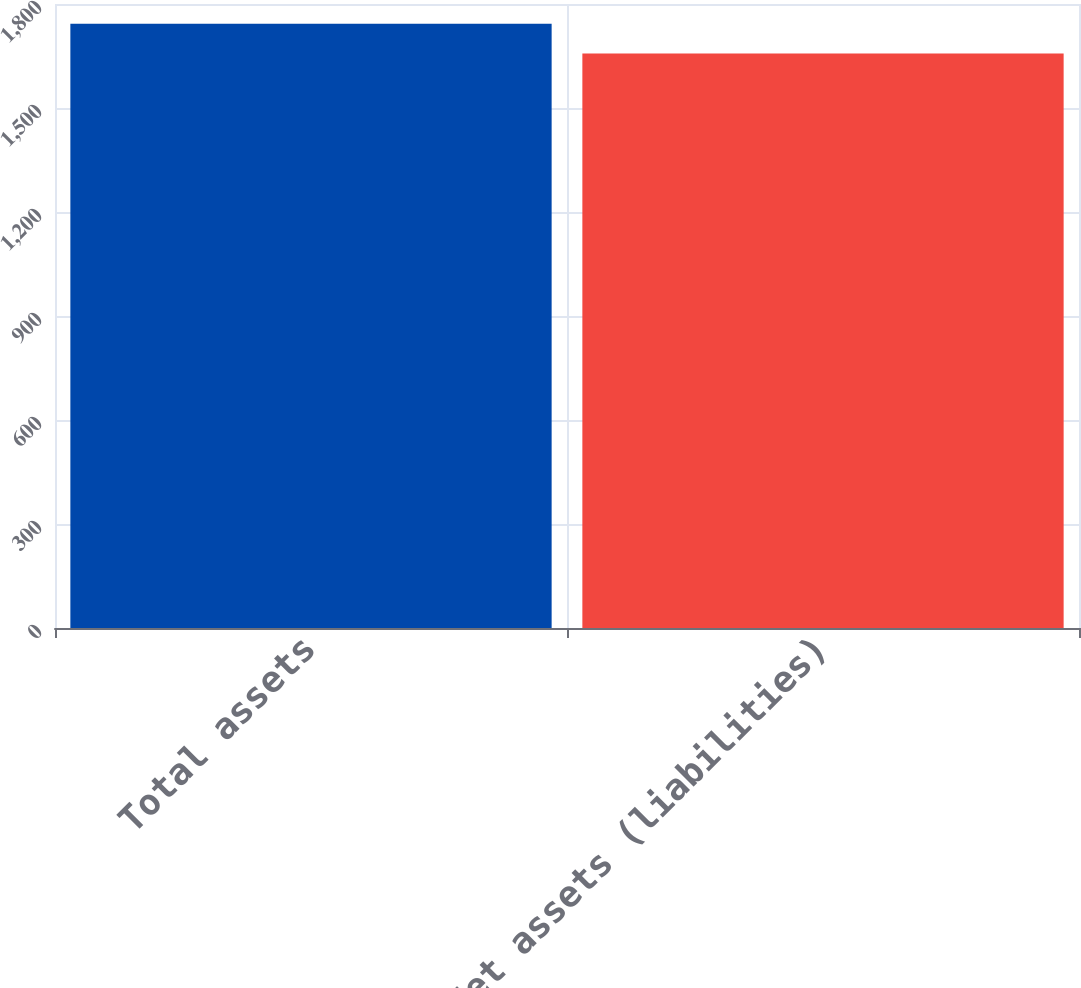Convert chart. <chart><loc_0><loc_0><loc_500><loc_500><bar_chart><fcel>Total assets<fcel>Net assets (liabilities)<nl><fcel>1743<fcel>1657<nl></chart> 